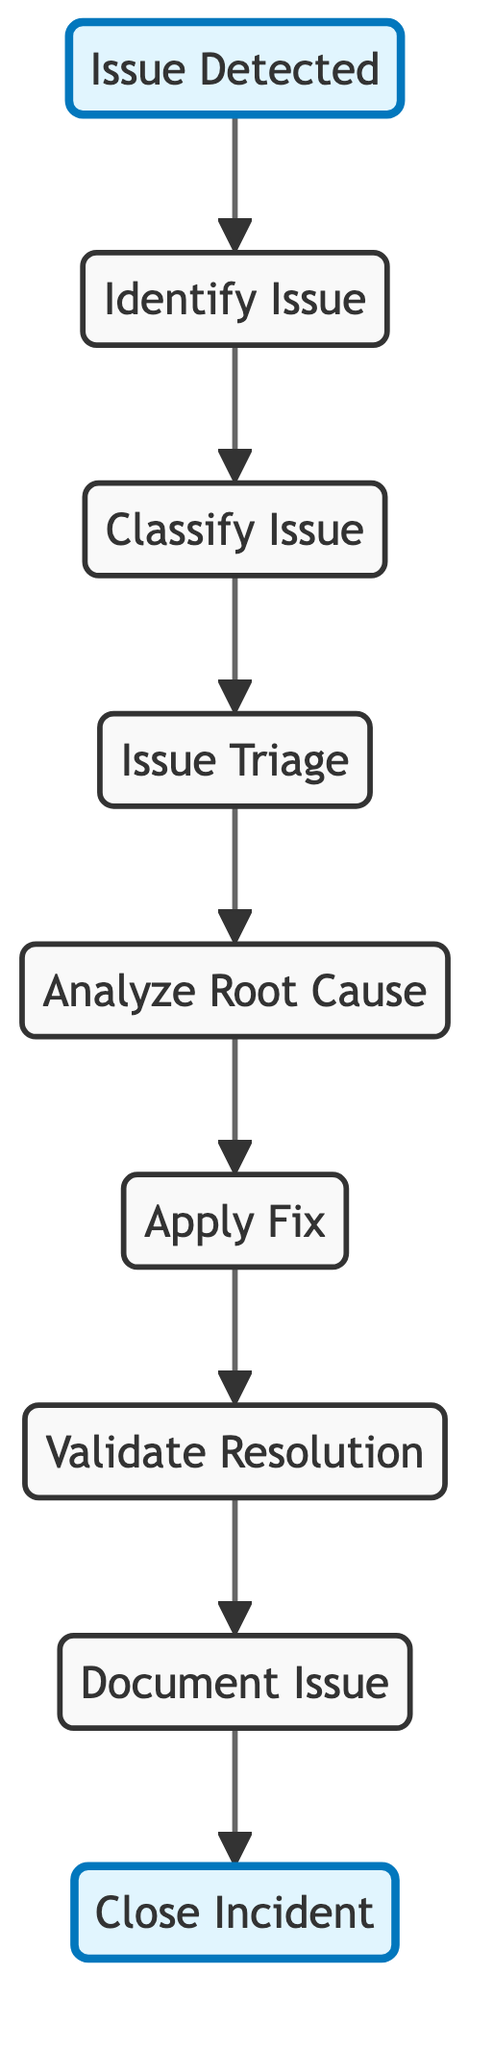What is the first step in the incident response workflow? The first step in the workflow is labeled as "Issue Detected" in the diagram. This is visually represented at the top of the flowchart and is highlighted, indicating its importance as the starting point.
Answer: Issue Detected How many distinct steps are outlined in the incident response workflow? The diagram contains a total of eight distinct steps, which include "Identify Issue," "Classify Issue," "Issue Triage," "Analyze Root Cause," "Apply Fix," "Validate Resolution," "Document Issue," and "Close Incident." Counting them gives a total of eight.
Answer: Eight What is the final step after validating the resolution? The final step after validating the resolution is "Close Incident," which is designated at the end of the flowchart and is highlighted, indicating it wraps up the incident response process.
Answer: Close Incident Which step comes immediately after the "Analyze Root Cause"? The step that comes immediately after "Analyze Root Cause" is "Apply Fix." This can be seen by following the directed arrows in the flowchart that connect these two nodes sequentially.
Answer: Apply Fix What two steps are highlighted in the diagram? The two highlighted steps in the diagram are "Issue Detected" and "Close Incident." These are visually distinct due to the highlighted style, showcasing their significance within the workflow.
Answer: Issue Detected, Close Incident What action is taken after an issue is triaged? After an issue is triaged, the action taken is "Analyze Root Cause." This transition is clearly depicted by the arrow connecting the "Issue Triage" to "Analyze Root Cause."
Answer: Analyze Root Cause Which steps involve a validation process? The validation process involves the steps "Validate Resolution" and "Document Issue." Both of these steps are part of the workflow but specifically highlight actions that ensure the response is effective.
Answer: Validate Resolution, Document Issue 